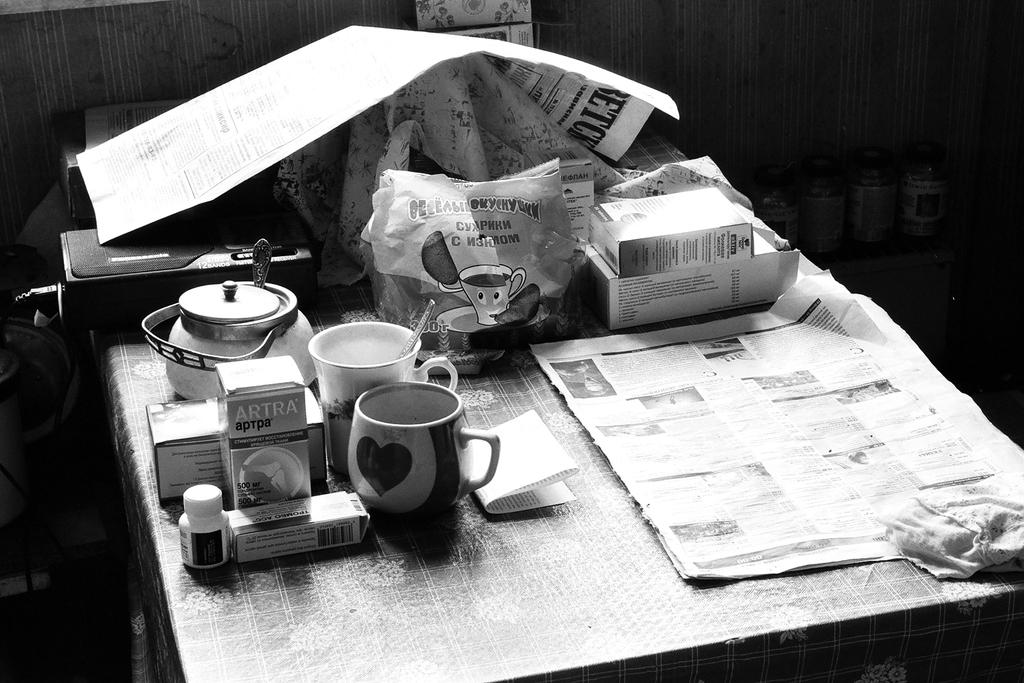What piece of furniture is present in the image? There is a table in the image. What is placed on the table? Papers and cups are placed on the table. Are there any other objects on the table? Yes, there are other objects on the table. What type of ring can be seen on the moon in the image? There is no ring or moon present in the image; it only features a table with papers, cups, and other objects. 